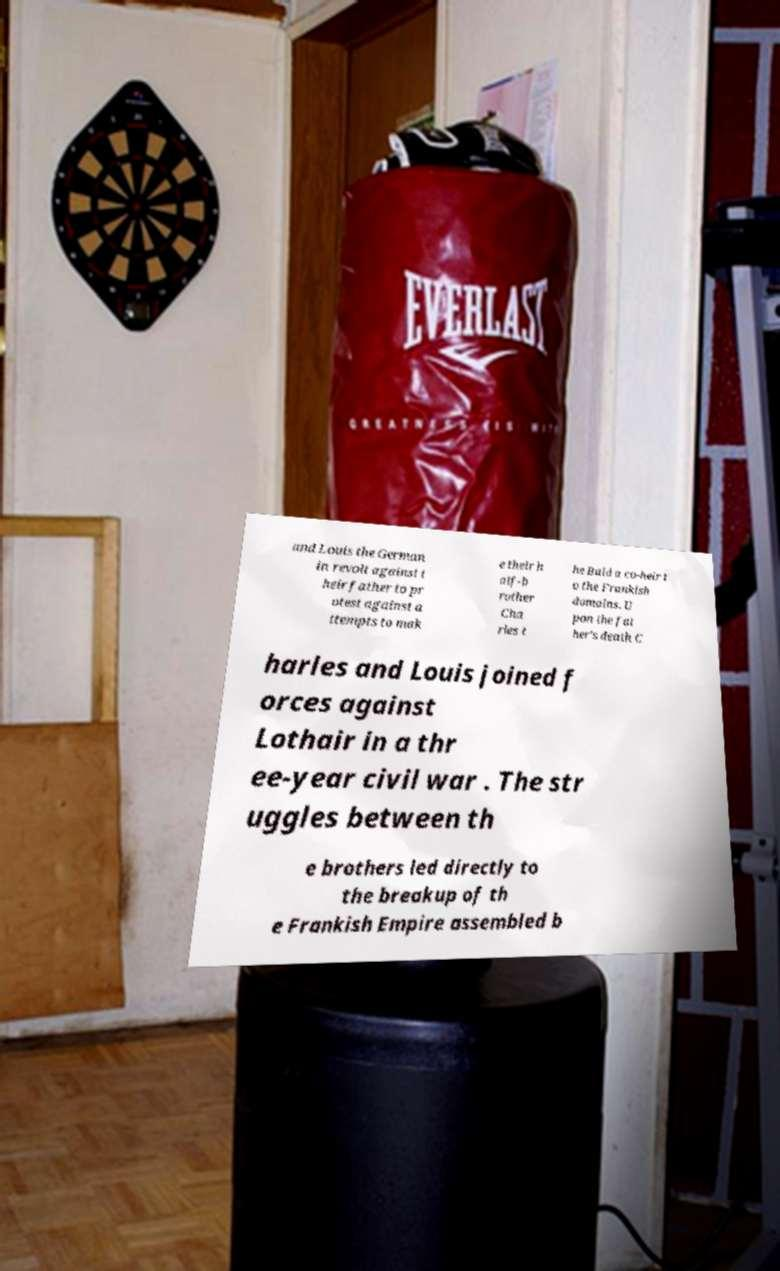Could you extract and type out the text from this image? and Louis the German in revolt against t heir father to pr otest against a ttempts to mak e their h alf-b rother Cha rles t he Bald a co-heir t o the Frankish domains. U pon the fat her's death C harles and Louis joined f orces against Lothair in a thr ee-year civil war . The str uggles between th e brothers led directly to the breakup of th e Frankish Empire assembled b 